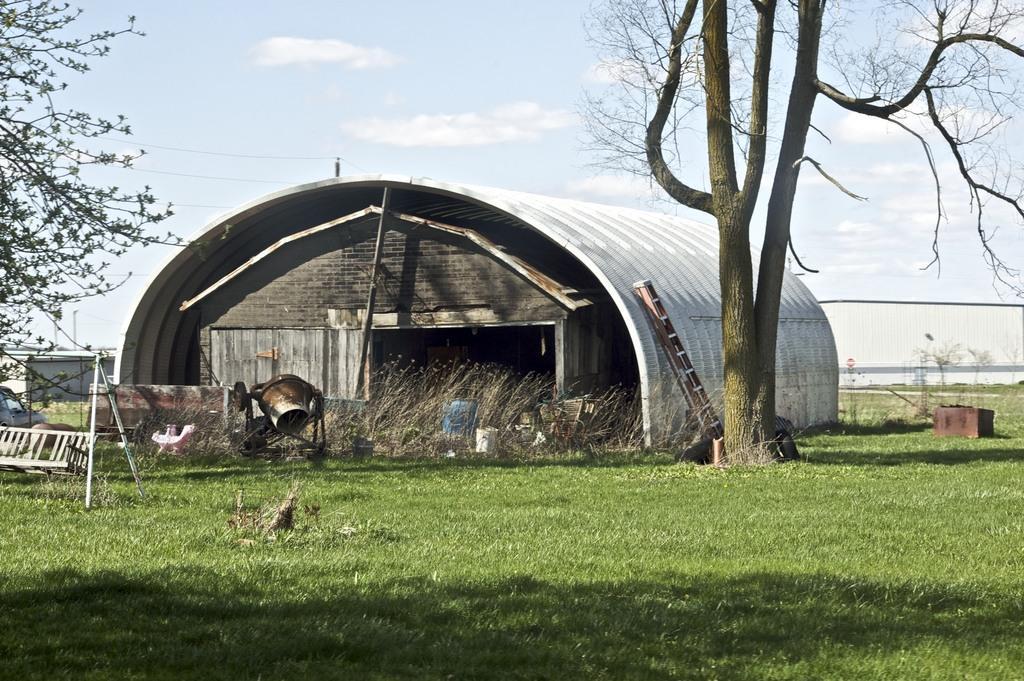In one or two sentences, can you explain what this image depicts? We can see grass, trees, poles, machine, ladder, shed and few objects. In the background we can see wall, poles, wires and sky with clouds. 